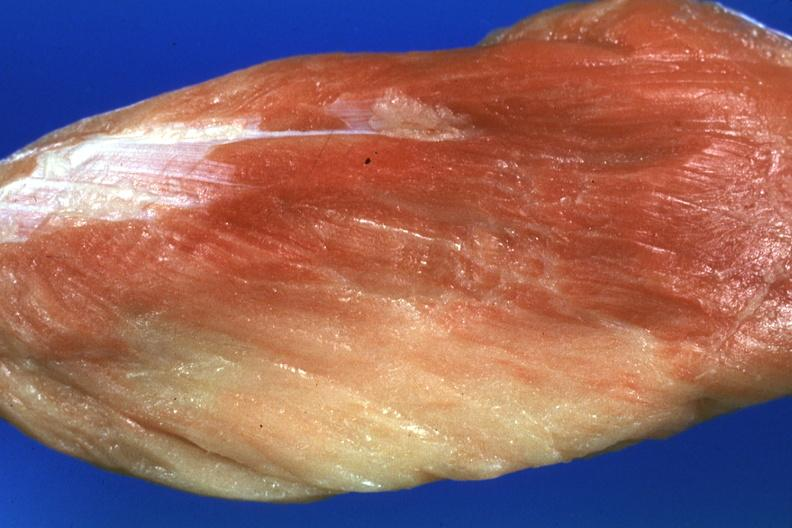s hemorrhage in newborn present?
Answer the question using a single word or phrase. No 